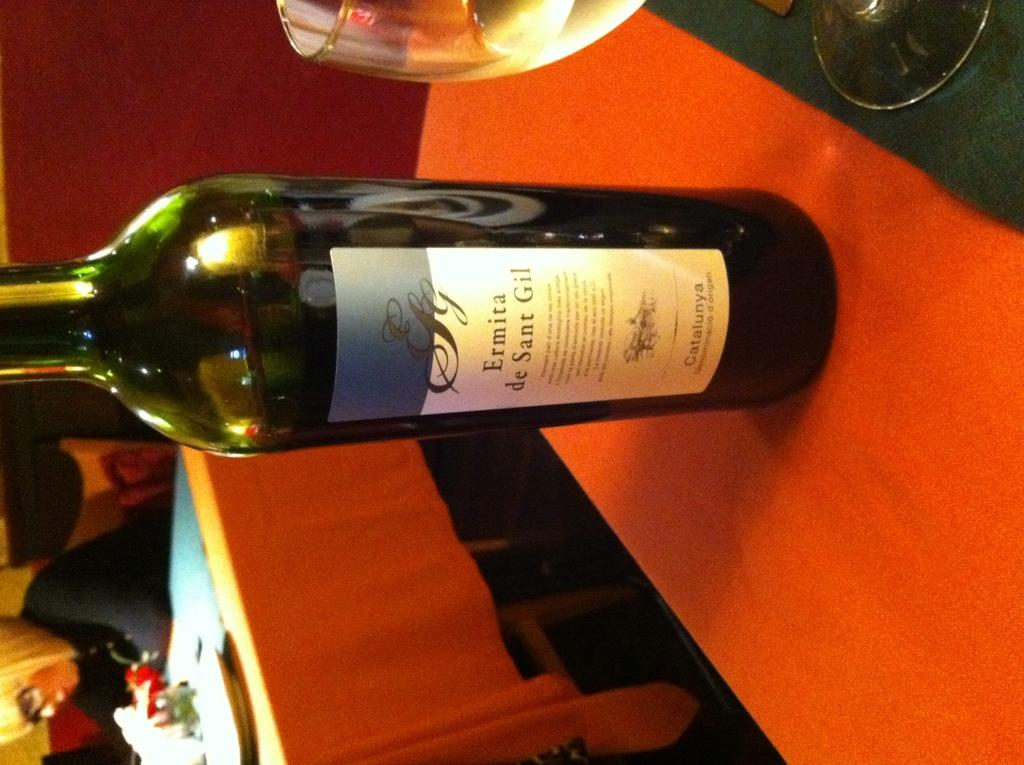<image>
Write a terse but informative summary of the picture. A bottle is labeled Ermita de Sant Gil. 